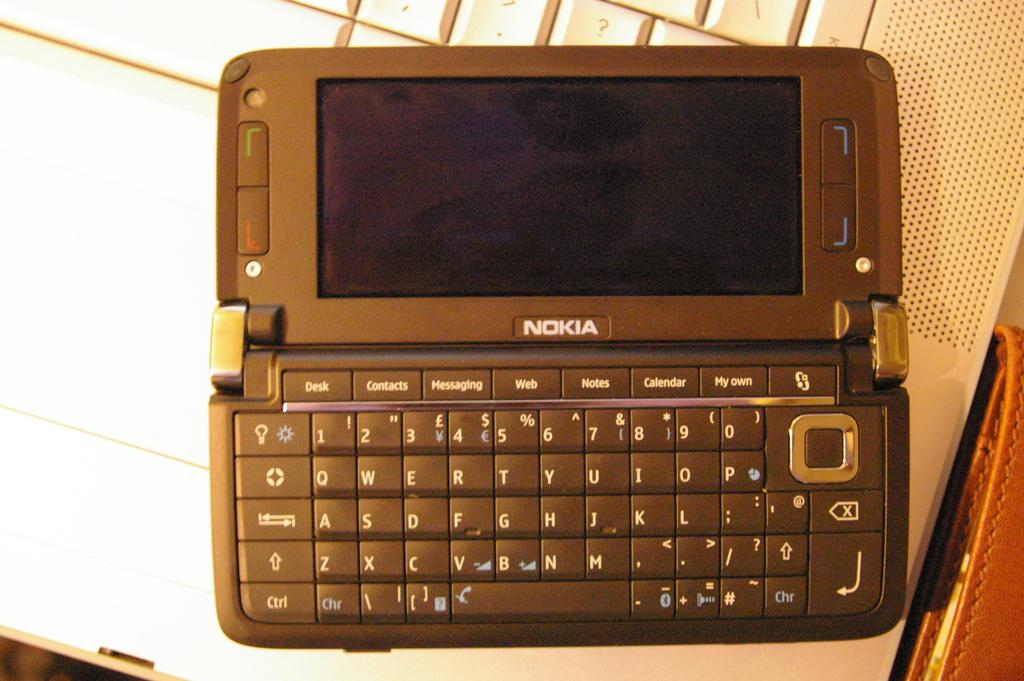<image>
Summarize the visual content of the image. A Nokia brand phone with a full-size keyboard features buttons like contacts and messaging. 